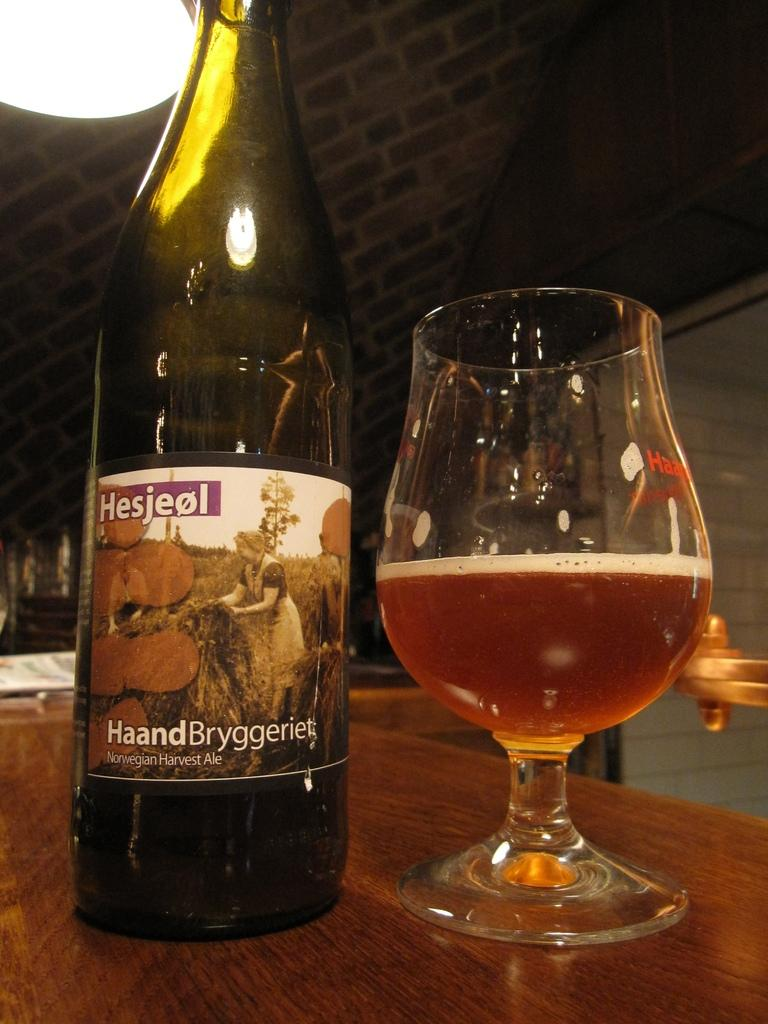What piece of furniture is present in the image? There is a table in the image. What is placed on the table? There is a glass tumbler with a beverage in it and a beverage bottle on the table. What type of suit is the person wearing in the image? There is no person present in the image, so it is not possible to determine what type of suit they might be wearing. 